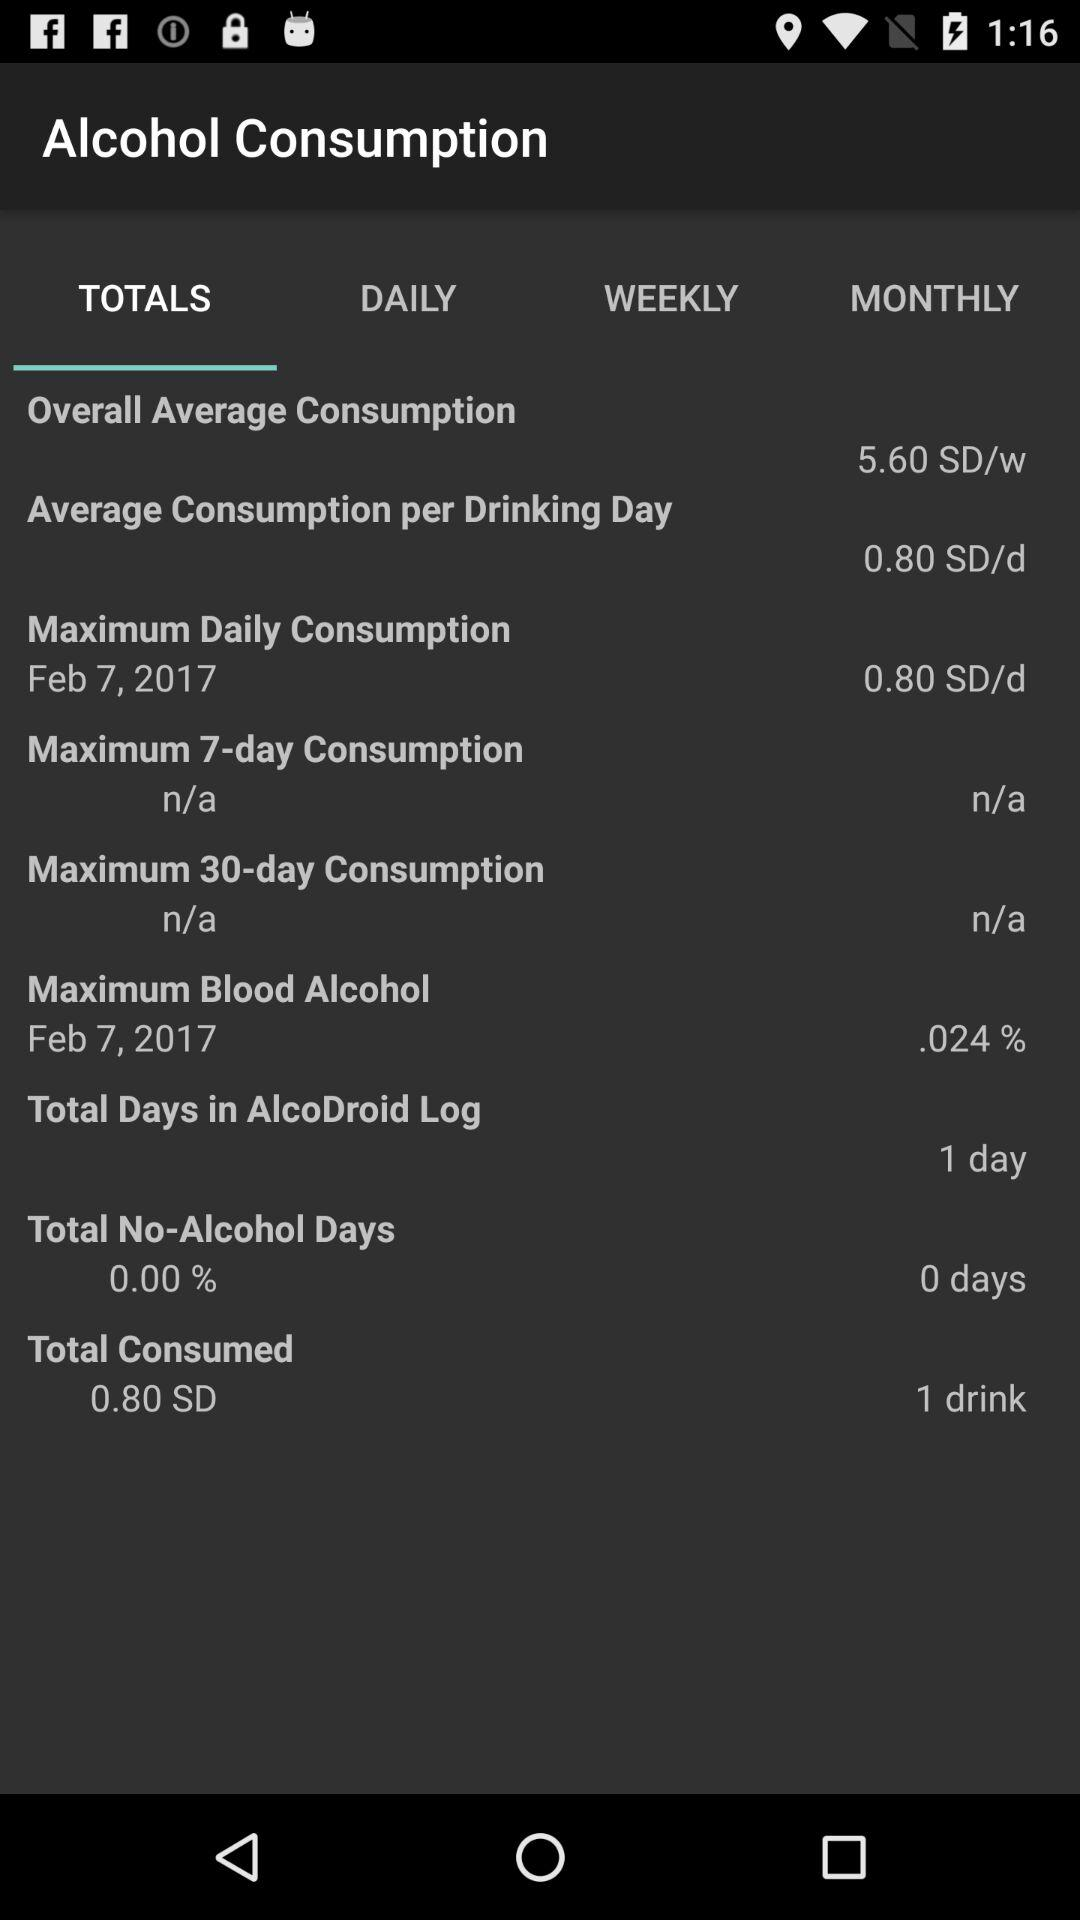What is the "Average Consumption per Drinking Day"? The "Average Consumption per Drinking Day" is 0.80 SD/d. 